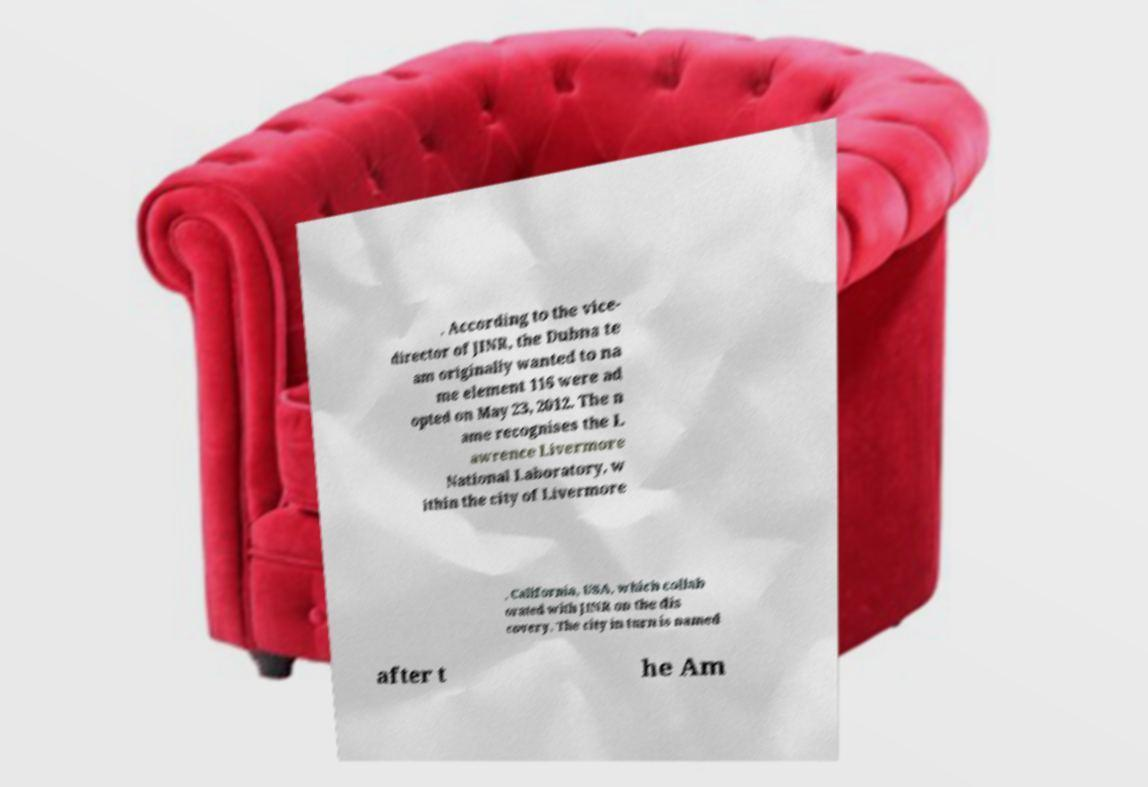Can you read and provide the text displayed in the image?This photo seems to have some interesting text. Can you extract and type it out for me? . According to the vice- director of JINR, the Dubna te am originally wanted to na me element 116 were ad opted on May 23, 2012. The n ame recognises the L awrence Livermore National Laboratory, w ithin the city of Livermore , California, USA, which collab orated with JINR on the dis covery. The city in turn is named after t he Am 